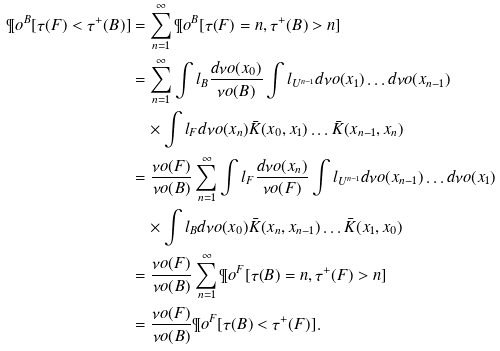Convert formula to latex. <formula><loc_0><loc_0><loc_500><loc_500>\P o ^ { B } [ \tau ( F ) < \tau ^ { + } ( B ) ] & = \sum _ { n = 1 } ^ { \infty } \P o ^ { B } [ \tau ( F ) = n , \tau ^ { + } ( B ) > n ] \\ & = \sum _ { n = 1 } ^ { \infty } \int l _ { B } \frac { d \nu o ( x _ { 0 } ) } { \nu o ( B ) } \int l _ { U ^ { n - 1 } } d \nu o ( x _ { 1 } ) \dots d \nu o ( x _ { n - 1 } ) \\ & \quad \times \int l _ { F } d \nu o ( x _ { n } ) { \bar { K } } ( x _ { 0 } , x _ { 1 } ) \dots { \bar { K } } ( x _ { n - 1 } , x _ { n } ) \\ & = \frac { \nu o ( F ) } { \nu o ( B ) } \sum _ { n = 1 } ^ { \infty } \int l _ { F } \frac { d \nu o ( x _ { n } ) } { \nu o ( F ) } \int l _ { U ^ { n - 1 } } d \nu o ( x _ { n - 1 } ) \dots d \nu o ( x _ { 1 } ) \\ & \quad \times \int l _ { B } d \nu o ( x _ { 0 } ) { \bar { K } } ( x _ { n } , x _ { n - 1 } ) \dots { \bar { K } } ( x _ { 1 } , x _ { 0 } ) \\ & = \frac { \nu o ( F ) } { \nu o ( B ) } \sum _ { n = 1 } ^ { \infty } \P o ^ { F } [ \tau ( B ) = n , \tau ^ { + } ( F ) > n ] \\ & = \frac { \nu o ( F ) } { \nu o ( B ) } \P o ^ { F } [ \tau ( B ) < \tau ^ { + } ( F ) ] .</formula> 